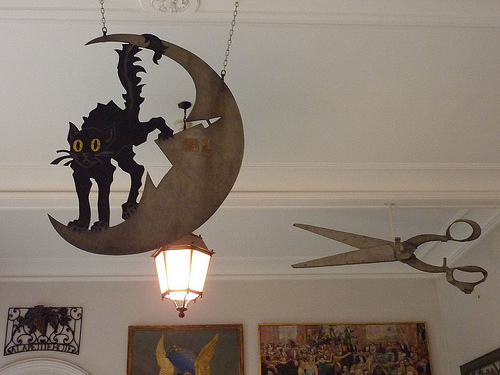<image>
Is there a picture in front of the wall? Yes. The picture is positioned in front of the wall, appearing closer to the camera viewpoint. 